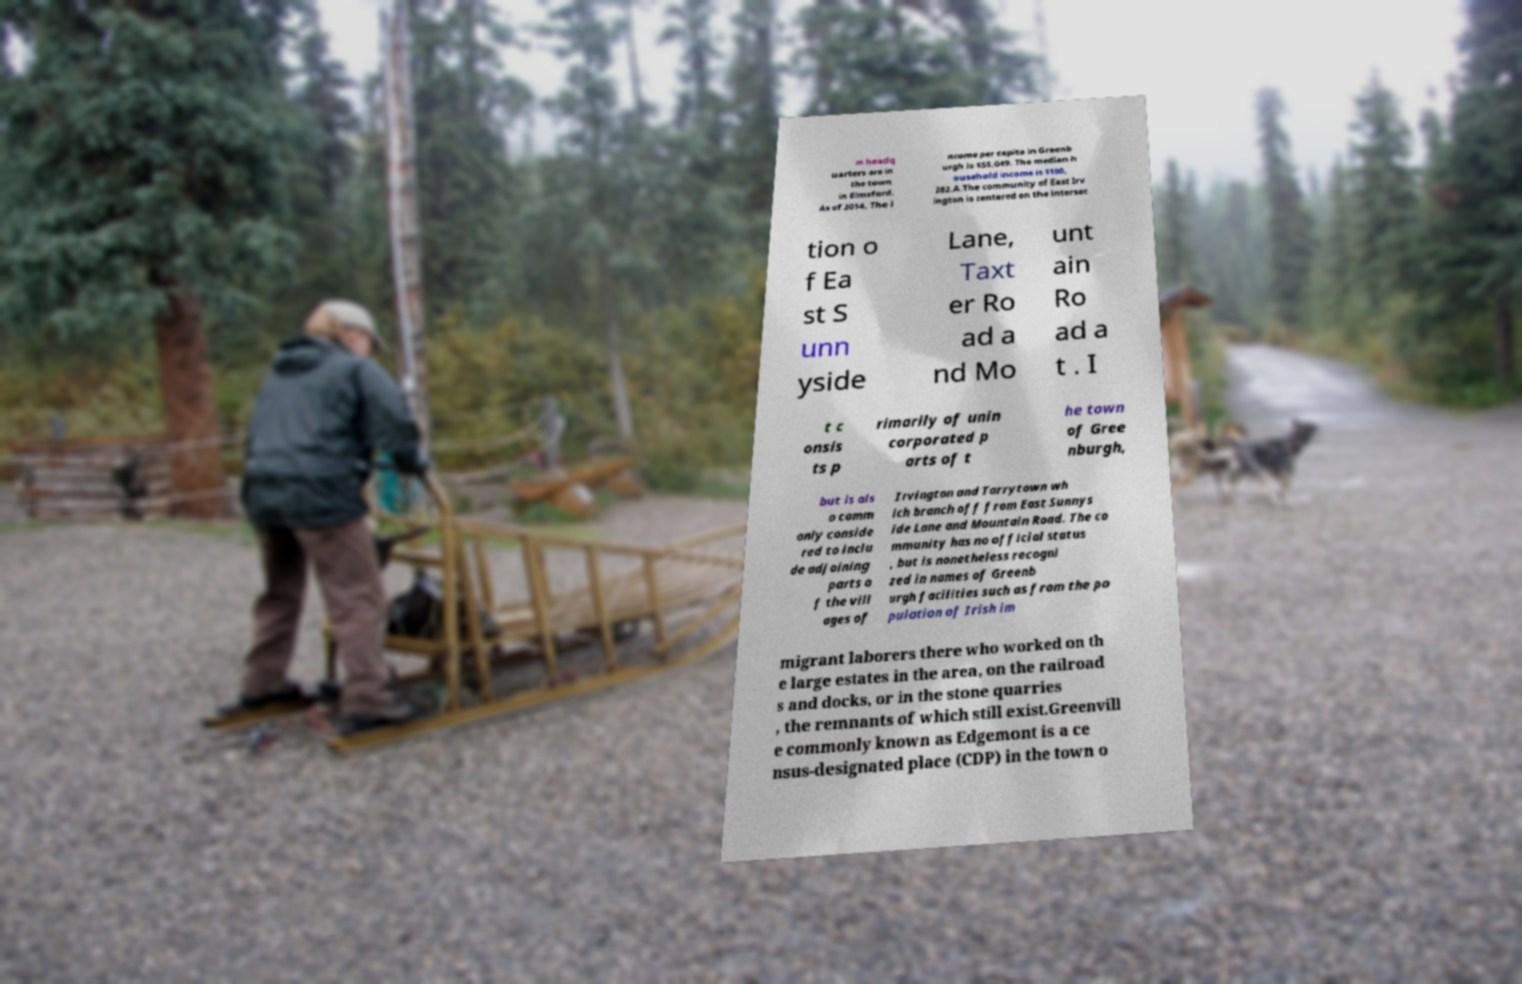What messages or text are displayed in this image? I need them in a readable, typed format. m headq uarters are in the town in Elmsford. As of 2014, The i ncome per capita in Greenb urgh is $55,049. The median h ousehold income is $100, 282.A.The community of East Irv ington is centered on the intersec tion o f Ea st S unn yside Lane, Taxt er Ro ad a nd Mo unt ain Ro ad a t . I t c onsis ts p rimarily of unin corporated p arts of t he town of Gree nburgh, but is als o comm only conside red to inclu de adjoining parts o f the vill ages of Irvington and Tarrytown wh ich branch off from East Sunnys ide Lane and Mountain Road. The co mmunity has no official status , but is nonetheless recogni zed in names of Greenb urgh facilities such as from the po pulation of Irish im migrant laborers there who worked on th e large estates in the area, on the railroad s and docks, or in the stone quarries , the remnants of which still exist.Greenvill e commonly known as Edgemont is a ce nsus-designated place (CDP) in the town o 